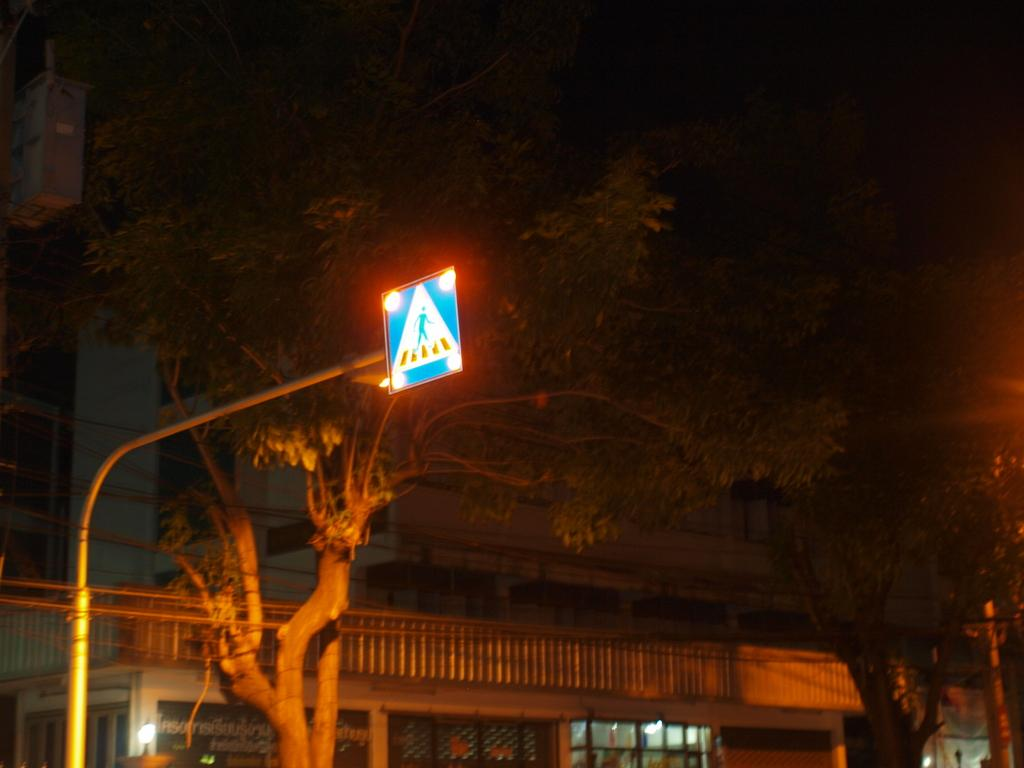What is on the pole in the image? There is a board with lights on a pole. What type of natural elements can be seen in the image? There are trees visible in the image. What is in the background of the image? There is a building in the background. What feature of the building is mentioned in the facts? Windows are present on the building. What type of book can be seen on the board with lights? There is no book present on the board with lights in the image. How many cherries are hanging from the trees in the image? There is no mention of cherries in the image, only trees are mentioned. 